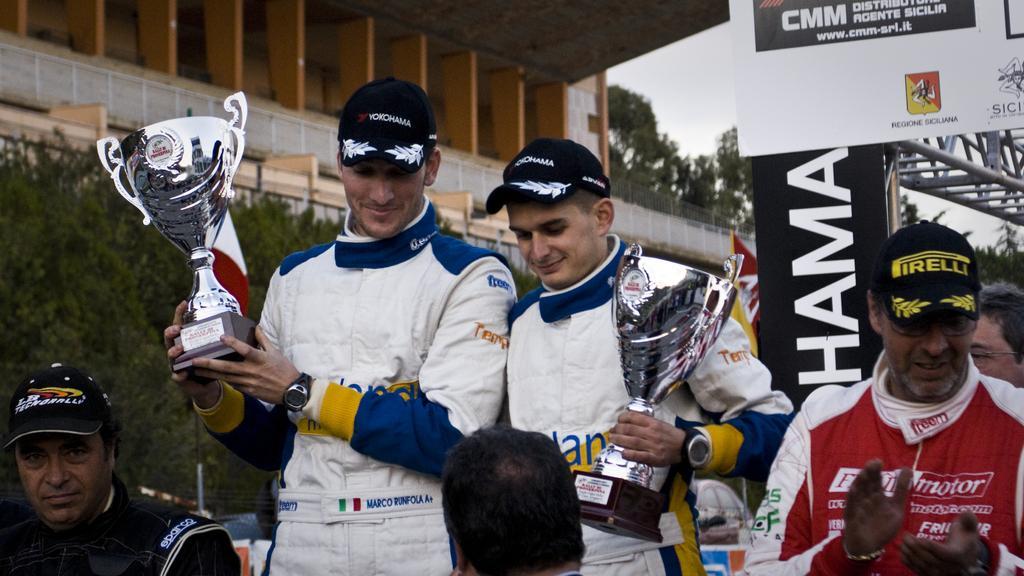Can you describe this image briefly? In the center of the image there are two persons holding a cups. At the bottom we can see persons. On the right side of the image we can see an advertisement and persons. In the background there is a building, trees and sky. 